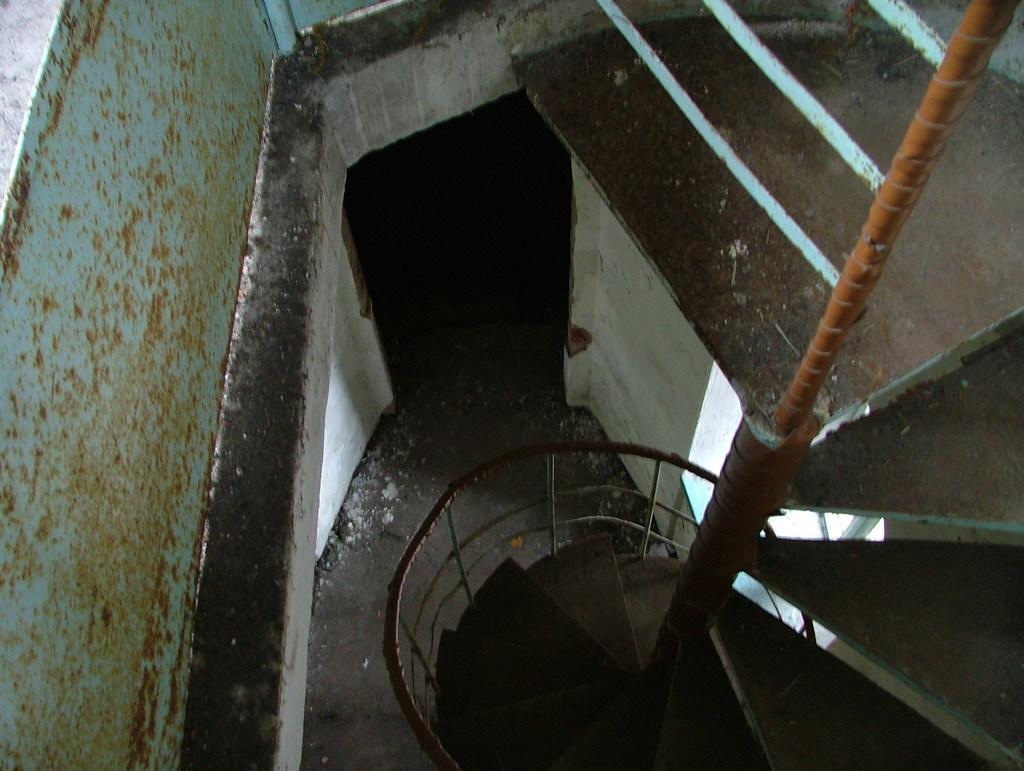How would you summarize this image in a sentence or two? In this image we can see the stairs, railing, floor, wall and also the rod. 